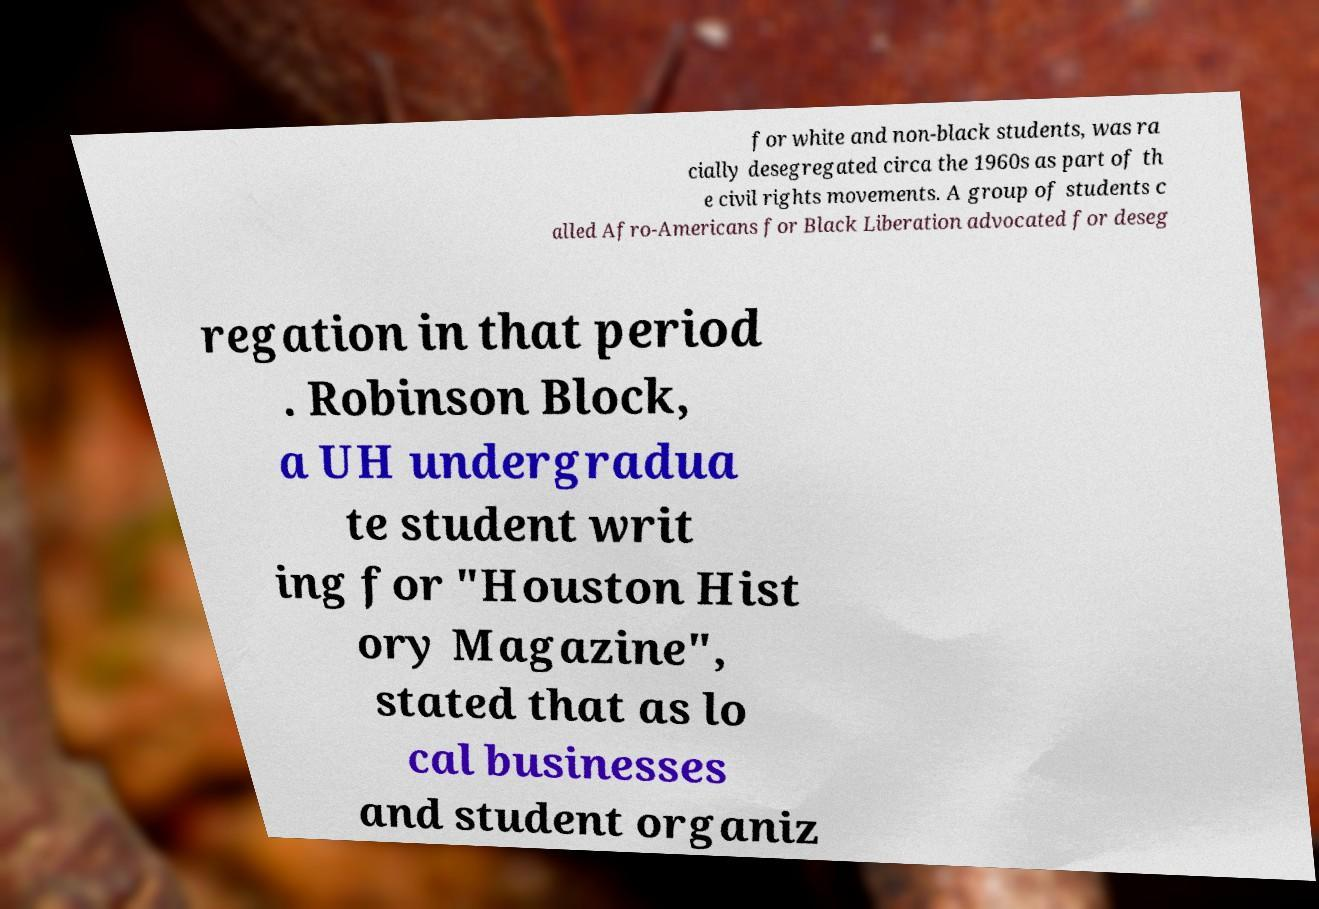What messages or text are displayed in this image? I need them in a readable, typed format. for white and non-black students, was ra cially desegregated circa the 1960s as part of th e civil rights movements. A group of students c alled Afro-Americans for Black Liberation advocated for deseg regation in that period . Robinson Block, a UH undergradua te student writ ing for "Houston Hist ory Magazine", stated that as lo cal businesses and student organiz 